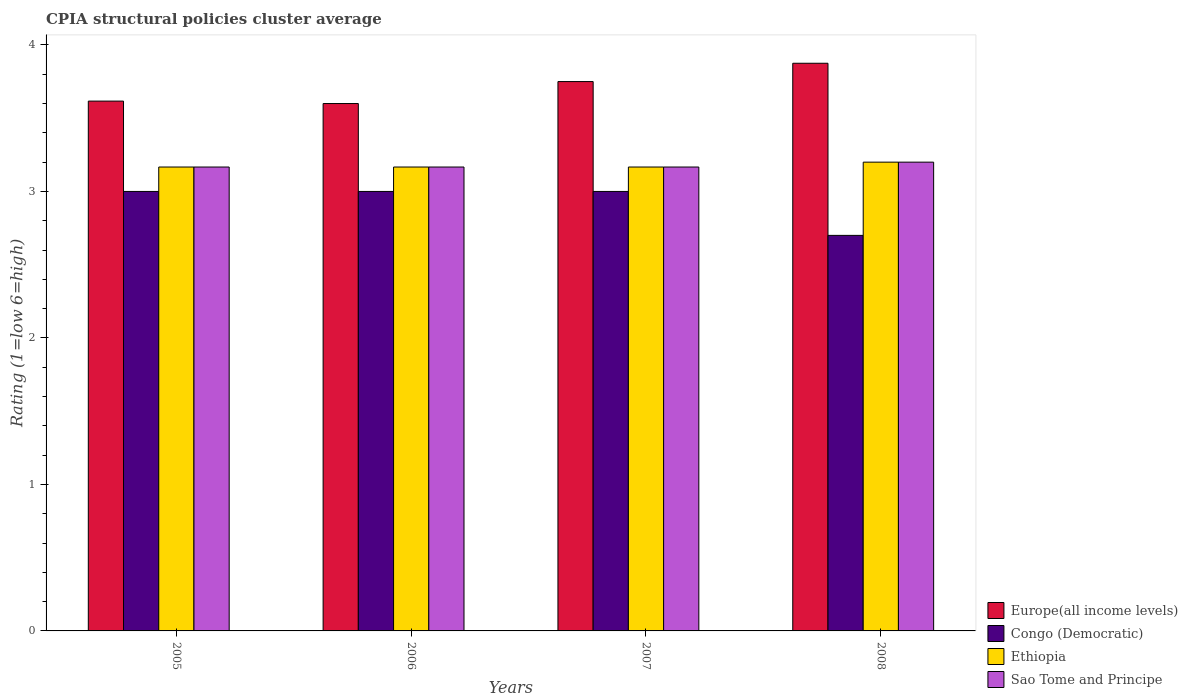How many different coloured bars are there?
Make the answer very short. 4. How many groups of bars are there?
Provide a short and direct response. 4. Are the number of bars per tick equal to the number of legend labels?
Provide a succinct answer. Yes. How many bars are there on the 3rd tick from the left?
Provide a succinct answer. 4. In how many cases, is the number of bars for a given year not equal to the number of legend labels?
Your answer should be very brief. 0. Across all years, what is the maximum CPIA rating in Europe(all income levels)?
Your answer should be compact. 3.88. Across all years, what is the minimum CPIA rating in Sao Tome and Principe?
Your answer should be compact. 3.17. In which year was the CPIA rating in Sao Tome and Principe minimum?
Your answer should be compact. 2005. What is the total CPIA rating in Congo (Democratic) in the graph?
Provide a succinct answer. 11.7. What is the difference between the CPIA rating in Europe(all income levels) in 2005 and that in 2008?
Offer a very short reply. -0.26. What is the difference between the CPIA rating in Europe(all income levels) in 2007 and the CPIA rating in Congo (Democratic) in 2005?
Provide a succinct answer. 0.75. What is the average CPIA rating in Ethiopia per year?
Make the answer very short. 3.18. In the year 2006, what is the difference between the CPIA rating in Ethiopia and CPIA rating in Sao Tome and Principe?
Your response must be concise. 0. What is the ratio of the CPIA rating in Ethiopia in 2006 to that in 2007?
Provide a short and direct response. 1. What is the difference between the highest and the second highest CPIA rating in Congo (Democratic)?
Your response must be concise. 0. What is the difference between the highest and the lowest CPIA rating in Sao Tome and Principe?
Offer a terse response. 0.03. What does the 2nd bar from the left in 2007 represents?
Give a very brief answer. Congo (Democratic). What does the 3rd bar from the right in 2007 represents?
Keep it short and to the point. Congo (Democratic). How many years are there in the graph?
Your answer should be compact. 4. What is the difference between two consecutive major ticks on the Y-axis?
Offer a very short reply. 1. Does the graph contain any zero values?
Offer a very short reply. No. Does the graph contain grids?
Give a very brief answer. No. Where does the legend appear in the graph?
Your answer should be very brief. Bottom right. How are the legend labels stacked?
Give a very brief answer. Vertical. What is the title of the graph?
Keep it short and to the point. CPIA structural policies cluster average. Does "Myanmar" appear as one of the legend labels in the graph?
Offer a terse response. No. What is the label or title of the X-axis?
Provide a succinct answer. Years. What is the label or title of the Y-axis?
Your response must be concise. Rating (1=low 6=high). What is the Rating (1=low 6=high) in Europe(all income levels) in 2005?
Your answer should be very brief. 3.62. What is the Rating (1=low 6=high) in Congo (Democratic) in 2005?
Your answer should be compact. 3. What is the Rating (1=low 6=high) of Ethiopia in 2005?
Your answer should be compact. 3.17. What is the Rating (1=low 6=high) in Sao Tome and Principe in 2005?
Your answer should be compact. 3.17. What is the Rating (1=low 6=high) in Europe(all income levels) in 2006?
Offer a terse response. 3.6. What is the Rating (1=low 6=high) in Congo (Democratic) in 2006?
Provide a short and direct response. 3. What is the Rating (1=low 6=high) of Ethiopia in 2006?
Your answer should be compact. 3.17. What is the Rating (1=low 6=high) of Sao Tome and Principe in 2006?
Make the answer very short. 3.17. What is the Rating (1=low 6=high) in Europe(all income levels) in 2007?
Offer a very short reply. 3.75. What is the Rating (1=low 6=high) in Ethiopia in 2007?
Make the answer very short. 3.17. What is the Rating (1=low 6=high) in Sao Tome and Principe in 2007?
Your response must be concise. 3.17. What is the Rating (1=low 6=high) of Europe(all income levels) in 2008?
Keep it short and to the point. 3.88. What is the Rating (1=low 6=high) of Congo (Democratic) in 2008?
Offer a terse response. 2.7. What is the Rating (1=low 6=high) of Sao Tome and Principe in 2008?
Your response must be concise. 3.2. Across all years, what is the maximum Rating (1=low 6=high) of Europe(all income levels)?
Your answer should be compact. 3.88. Across all years, what is the minimum Rating (1=low 6=high) in Ethiopia?
Keep it short and to the point. 3.17. Across all years, what is the minimum Rating (1=low 6=high) of Sao Tome and Principe?
Your response must be concise. 3.17. What is the total Rating (1=low 6=high) in Europe(all income levels) in the graph?
Make the answer very short. 14.84. What is the total Rating (1=low 6=high) in Congo (Democratic) in the graph?
Your answer should be very brief. 11.7. What is the difference between the Rating (1=low 6=high) of Europe(all income levels) in 2005 and that in 2006?
Provide a short and direct response. 0.02. What is the difference between the Rating (1=low 6=high) in Congo (Democratic) in 2005 and that in 2006?
Make the answer very short. 0. What is the difference between the Rating (1=low 6=high) of Ethiopia in 2005 and that in 2006?
Keep it short and to the point. 0. What is the difference between the Rating (1=low 6=high) in Sao Tome and Principe in 2005 and that in 2006?
Your answer should be very brief. 0. What is the difference between the Rating (1=low 6=high) in Europe(all income levels) in 2005 and that in 2007?
Provide a succinct answer. -0.13. What is the difference between the Rating (1=low 6=high) of Sao Tome and Principe in 2005 and that in 2007?
Offer a very short reply. 0. What is the difference between the Rating (1=low 6=high) in Europe(all income levels) in 2005 and that in 2008?
Your response must be concise. -0.26. What is the difference between the Rating (1=low 6=high) in Ethiopia in 2005 and that in 2008?
Offer a terse response. -0.03. What is the difference between the Rating (1=low 6=high) of Sao Tome and Principe in 2005 and that in 2008?
Offer a very short reply. -0.03. What is the difference between the Rating (1=low 6=high) of Europe(all income levels) in 2006 and that in 2007?
Give a very brief answer. -0.15. What is the difference between the Rating (1=low 6=high) of Europe(all income levels) in 2006 and that in 2008?
Provide a short and direct response. -0.28. What is the difference between the Rating (1=low 6=high) of Congo (Democratic) in 2006 and that in 2008?
Offer a terse response. 0.3. What is the difference between the Rating (1=low 6=high) of Ethiopia in 2006 and that in 2008?
Provide a succinct answer. -0.03. What is the difference between the Rating (1=low 6=high) of Sao Tome and Principe in 2006 and that in 2008?
Your response must be concise. -0.03. What is the difference between the Rating (1=low 6=high) of Europe(all income levels) in 2007 and that in 2008?
Ensure brevity in your answer.  -0.12. What is the difference between the Rating (1=low 6=high) in Ethiopia in 2007 and that in 2008?
Provide a short and direct response. -0.03. What is the difference between the Rating (1=low 6=high) of Sao Tome and Principe in 2007 and that in 2008?
Give a very brief answer. -0.03. What is the difference between the Rating (1=low 6=high) of Europe(all income levels) in 2005 and the Rating (1=low 6=high) of Congo (Democratic) in 2006?
Offer a very short reply. 0.62. What is the difference between the Rating (1=low 6=high) in Europe(all income levels) in 2005 and the Rating (1=low 6=high) in Ethiopia in 2006?
Provide a short and direct response. 0.45. What is the difference between the Rating (1=low 6=high) of Europe(all income levels) in 2005 and the Rating (1=low 6=high) of Sao Tome and Principe in 2006?
Your answer should be very brief. 0.45. What is the difference between the Rating (1=low 6=high) in Congo (Democratic) in 2005 and the Rating (1=low 6=high) in Ethiopia in 2006?
Provide a short and direct response. -0.17. What is the difference between the Rating (1=low 6=high) in Congo (Democratic) in 2005 and the Rating (1=low 6=high) in Sao Tome and Principe in 2006?
Give a very brief answer. -0.17. What is the difference between the Rating (1=low 6=high) in Ethiopia in 2005 and the Rating (1=low 6=high) in Sao Tome and Principe in 2006?
Ensure brevity in your answer.  0. What is the difference between the Rating (1=low 6=high) of Europe(all income levels) in 2005 and the Rating (1=low 6=high) of Congo (Democratic) in 2007?
Give a very brief answer. 0.62. What is the difference between the Rating (1=low 6=high) in Europe(all income levels) in 2005 and the Rating (1=low 6=high) in Ethiopia in 2007?
Provide a short and direct response. 0.45. What is the difference between the Rating (1=low 6=high) in Europe(all income levels) in 2005 and the Rating (1=low 6=high) in Sao Tome and Principe in 2007?
Your answer should be compact. 0.45. What is the difference between the Rating (1=low 6=high) in Congo (Democratic) in 2005 and the Rating (1=low 6=high) in Ethiopia in 2007?
Your answer should be very brief. -0.17. What is the difference between the Rating (1=low 6=high) in Europe(all income levels) in 2005 and the Rating (1=low 6=high) in Congo (Democratic) in 2008?
Make the answer very short. 0.92. What is the difference between the Rating (1=low 6=high) in Europe(all income levels) in 2005 and the Rating (1=low 6=high) in Ethiopia in 2008?
Give a very brief answer. 0.42. What is the difference between the Rating (1=low 6=high) of Europe(all income levels) in 2005 and the Rating (1=low 6=high) of Sao Tome and Principe in 2008?
Your answer should be very brief. 0.42. What is the difference between the Rating (1=low 6=high) of Congo (Democratic) in 2005 and the Rating (1=low 6=high) of Sao Tome and Principe in 2008?
Your response must be concise. -0.2. What is the difference between the Rating (1=low 6=high) in Ethiopia in 2005 and the Rating (1=low 6=high) in Sao Tome and Principe in 2008?
Your answer should be compact. -0.03. What is the difference between the Rating (1=low 6=high) of Europe(all income levels) in 2006 and the Rating (1=low 6=high) of Congo (Democratic) in 2007?
Give a very brief answer. 0.6. What is the difference between the Rating (1=low 6=high) of Europe(all income levels) in 2006 and the Rating (1=low 6=high) of Ethiopia in 2007?
Provide a succinct answer. 0.43. What is the difference between the Rating (1=low 6=high) in Europe(all income levels) in 2006 and the Rating (1=low 6=high) in Sao Tome and Principe in 2007?
Make the answer very short. 0.43. What is the difference between the Rating (1=low 6=high) of Congo (Democratic) in 2006 and the Rating (1=low 6=high) of Sao Tome and Principe in 2007?
Offer a very short reply. -0.17. What is the difference between the Rating (1=low 6=high) of Europe(all income levels) in 2006 and the Rating (1=low 6=high) of Congo (Democratic) in 2008?
Provide a succinct answer. 0.9. What is the difference between the Rating (1=low 6=high) in Europe(all income levels) in 2006 and the Rating (1=low 6=high) in Ethiopia in 2008?
Provide a short and direct response. 0.4. What is the difference between the Rating (1=low 6=high) in Congo (Democratic) in 2006 and the Rating (1=low 6=high) in Ethiopia in 2008?
Provide a succinct answer. -0.2. What is the difference between the Rating (1=low 6=high) in Congo (Democratic) in 2006 and the Rating (1=low 6=high) in Sao Tome and Principe in 2008?
Offer a terse response. -0.2. What is the difference between the Rating (1=low 6=high) in Ethiopia in 2006 and the Rating (1=low 6=high) in Sao Tome and Principe in 2008?
Offer a terse response. -0.03. What is the difference between the Rating (1=low 6=high) of Europe(all income levels) in 2007 and the Rating (1=low 6=high) of Ethiopia in 2008?
Your answer should be very brief. 0.55. What is the difference between the Rating (1=low 6=high) of Europe(all income levels) in 2007 and the Rating (1=low 6=high) of Sao Tome and Principe in 2008?
Your response must be concise. 0.55. What is the difference between the Rating (1=low 6=high) of Congo (Democratic) in 2007 and the Rating (1=low 6=high) of Sao Tome and Principe in 2008?
Your answer should be compact. -0.2. What is the difference between the Rating (1=low 6=high) in Ethiopia in 2007 and the Rating (1=low 6=high) in Sao Tome and Principe in 2008?
Provide a succinct answer. -0.03. What is the average Rating (1=low 6=high) of Europe(all income levels) per year?
Ensure brevity in your answer.  3.71. What is the average Rating (1=low 6=high) in Congo (Democratic) per year?
Your response must be concise. 2.92. What is the average Rating (1=low 6=high) in Ethiopia per year?
Make the answer very short. 3.17. What is the average Rating (1=low 6=high) in Sao Tome and Principe per year?
Offer a very short reply. 3.17. In the year 2005, what is the difference between the Rating (1=low 6=high) of Europe(all income levels) and Rating (1=low 6=high) of Congo (Democratic)?
Your answer should be very brief. 0.62. In the year 2005, what is the difference between the Rating (1=low 6=high) of Europe(all income levels) and Rating (1=low 6=high) of Ethiopia?
Offer a terse response. 0.45. In the year 2005, what is the difference between the Rating (1=low 6=high) in Europe(all income levels) and Rating (1=low 6=high) in Sao Tome and Principe?
Offer a very short reply. 0.45. In the year 2005, what is the difference between the Rating (1=low 6=high) in Congo (Democratic) and Rating (1=low 6=high) in Ethiopia?
Ensure brevity in your answer.  -0.17. In the year 2006, what is the difference between the Rating (1=low 6=high) in Europe(all income levels) and Rating (1=low 6=high) in Ethiopia?
Offer a terse response. 0.43. In the year 2006, what is the difference between the Rating (1=low 6=high) in Europe(all income levels) and Rating (1=low 6=high) in Sao Tome and Principe?
Provide a short and direct response. 0.43. In the year 2006, what is the difference between the Rating (1=low 6=high) in Congo (Democratic) and Rating (1=low 6=high) in Ethiopia?
Your response must be concise. -0.17. In the year 2006, what is the difference between the Rating (1=low 6=high) in Ethiopia and Rating (1=low 6=high) in Sao Tome and Principe?
Offer a very short reply. 0. In the year 2007, what is the difference between the Rating (1=low 6=high) of Europe(all income levels) and Rating (1=low 6=high) of Ethiopia?
Keep it short and to the point. 0.58. In the year 2007, what is the difference between the Rating (1=low 6=high) in Europe(all income levels) and Rating (1=low 6=high) in Sao Tome and Principe?
Provide a succinct answer. 0.58. In the year 2007, what is the difference between the Rating (1=low 6=high) of Congo (Democratic) and Rating (1=low 6=high) of Ethiopia?
Ensure brevity in your answer.  -0.17. In the year 2007, what is the difference between the Rating (1=low 6=high) in Ethiopia and Rating (1=low 6=high) in Sao Tome and Principe?
Keep it short and to the point. 0. In the year 2008, what is the difference between the Rating (1=low 6=high) of Europe(all income levels) and Rating (1=low 6=high) of Congo (Democratic)?
Keep it short and to the point. 1.18. In the year 2008, what is the difference between the Rating (1=low 6=high) of Europe(all income levels) and Rating (1=low 6=high) of Ethiopia?
Provide a succinct answer. 0.68. In the year 2008, what is the difference between the Rating (1=low 6=high) of Europe(all income levels) and Rating (1=low 6=high) of Sao Tome and Principe?
Provide a short and direct response. 0.68. In the year 2008, what is the difference between the Rating (1=low 6=high) in Congo (Democratic) and Rating (1=low 6=high) in Ethiopia?
Your answer should be compact. -0.5. What is the ratio of the Rating (1=low 6=high) of Sao Tome and Principe in 2005 to that in 2006?
Your response must be concise. 1. What is the ratio of the Rating (1=low 6=high) of Europe(all income levels) in 2005 to that in 2007?
Provide a short and direct response. 0.96. What is the ratio of the Rating (1=low 6=high) in Congo (Democratic) in 2005 to that in 2007?
Offer a very short reply. 1. What is the ratio of the Rating (1=low 6=high) in Sao Tome and Principe in 2005 to that in 2008?
Give a very brief answer. 0.99. What is the ratio of the Rating (1=low 6=high) of Sao Tome and Principe in 2006 to that in 2007?
Give a very brief answer. 1. What is the ratio of the Rating (1=low 6=high) of Europe(all income levels) in 2006 to that in 2008?
Your answer should be very brief. 0.93. What is the ratio of the Rating (1=low 6=high) of Congo (Democratic) in 2006 to that in 2008?
Your answer should be very brief. 1.11. What is the ratio of the Rating (1=low 6=high) of Ethiopia in 2006 to that in 2008?
Offer a terse response. 0.99. What is the ratio of the Rating (1=low 6=high) of Europe(all income levels) in 2007 to that in 2008?
Give a very brief answer. 0.97. What is the ratio of the Rating (1=low 6=high) of Congo (Democratic) in 2007 to that in 2008?
Offer a very short reply. 1.11. What is the ratio of the Rating (1=low 6=high) of Ethiopia in 2007 to that in 2008?
Keep it short and to the point. 0.99. What is the ratio of the Rating (1=low 6=high) in Sao Tome and Principe in 2007 to that in 2008?
Ensure brevity in your answer.  0.99. What is the difference between the highest and the second highest Rating (1=low 6=high) in Congo (Democratic)?
Your response must be concise. 0. What is the difference between the highest and the lowest Rating (1=low 6=high) in Europe(all income levels)?
Your answer should be very brief. 0.28. What is the difference between the highest and the lowest Rating (1=low 6=high) in Congo (Democratic)?
Keep it short and to the point. 0.3. 